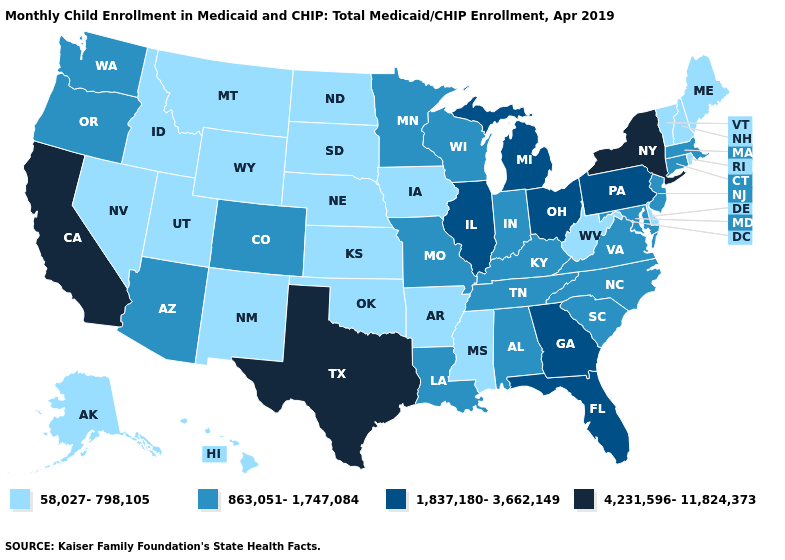Does California have the highest value in the West?
Keep it brief. Yes. What is the value of Wyoming?
Be succinct. 58,027-798,105. What is the lowest value in the USA?
Give a very brief answer. 58,027-798,105. Does New York have the highest value in the USA?
Answer briefly. Yes. Name the states that have a value in the range 863,051-1,747,084?
Quick response, please. Alabama, Arizona, Colorado, Connecticut, Indiana, Kentucky, Louisiana, Maryland, Massachusetts, Minnesota, Missouri, New Jersey, North Carolina, Oregon, South Carolina, Tennessee, Virginia, Washington, Wisconsin. What is the value of North Dakota?
Be succinct. 58,027-798,105. What is the lowest value in the USA?
Short answer required. 58,027-798,105. What is the highest value in states that border Indiana?
Answer briefly. 1,837,180-3,662,149. What is the value of Wisconsin?
Quick response, please. 863,051-1,747,084. Which states have the highest value in the USA?
Short answer required. California, New York, Texas. What is the value of Pennsylvania?
Write a very short answer. 1,837,180-3,662,149. Among the states that border Virginia , does West Virginia have the lowest value?
Quick response, please. Yes. How many symbols are there in the legend?
Give a very brief answer. 4. Does the map have missing data?
Short answer required. No. What is the highest value in the MidWest ?
Answer briefly. 1,837,180-3,662,149. 